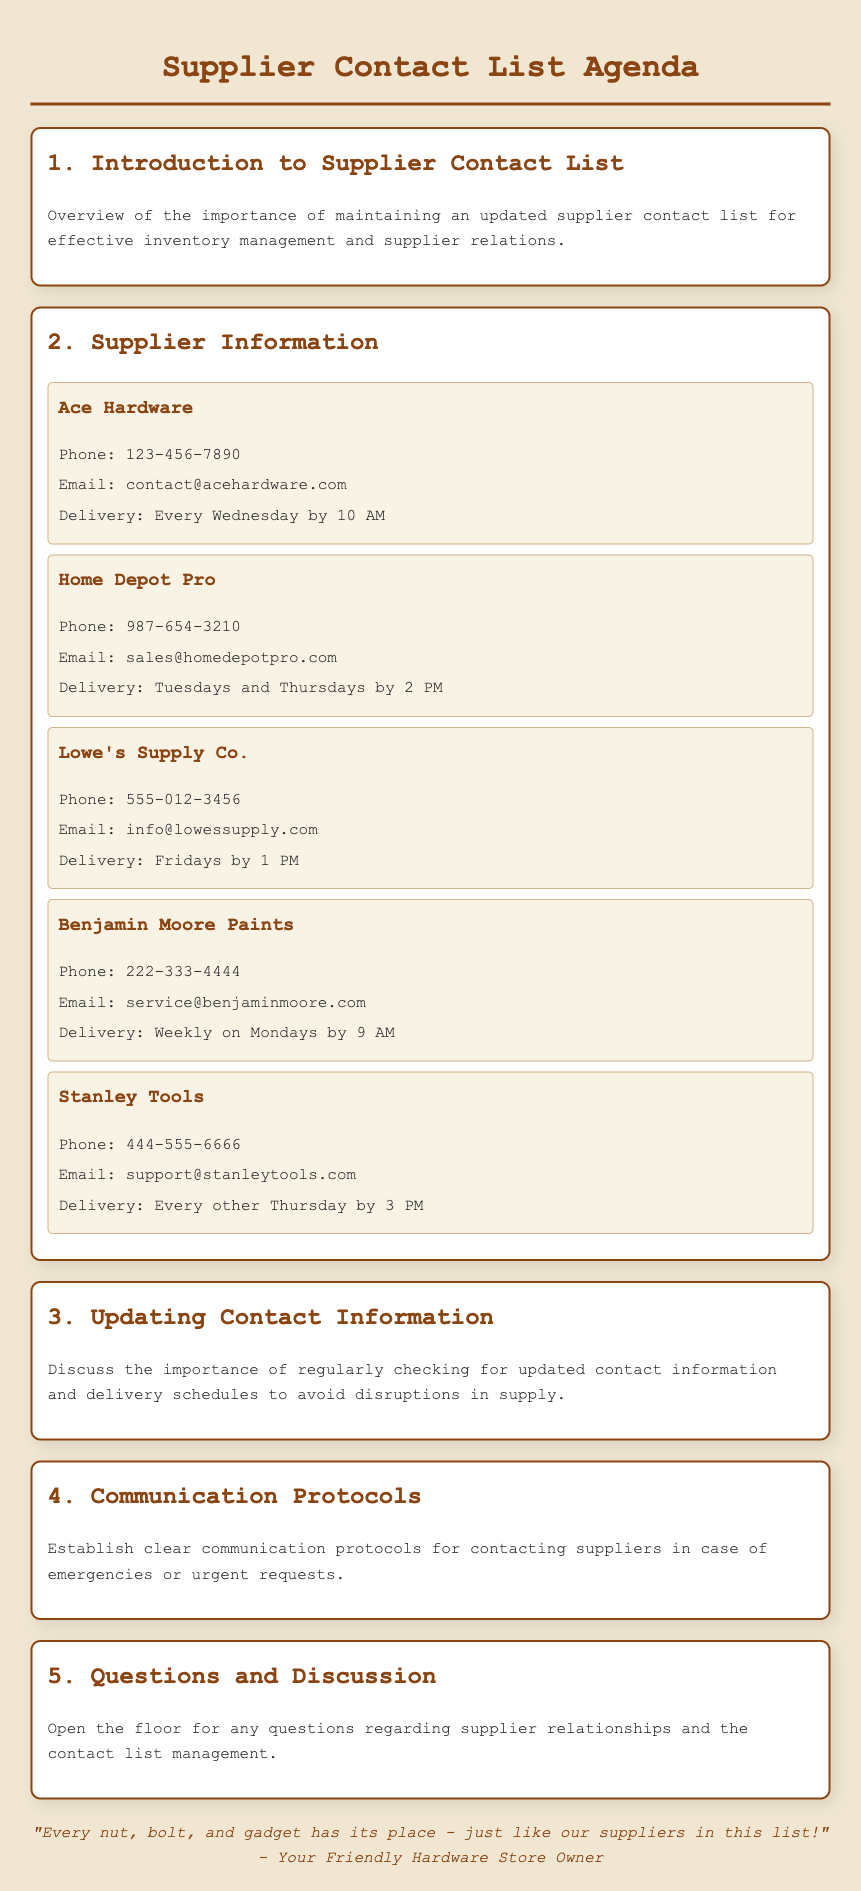What is the phone number for Ace Hardware? The phone number for Ace Hardware is listed in the supplier information section.
Answer: 123-456-7890 What are the delivery days for Home Depot Pro? The delivery days for Home Depot Pro are specified in the supplier information section.
Answer: Tuesdays and Thursdays What is the email address for Stanley Tools? The email address for Stanley Tools is provided in the supplier details.
Answer: support@stanleytools.com How often does Benjamin Moore Paints deliver? The frequency of delivery for Benjamin Moore Paints is mentioned in the document.
Answer: Weekly What is the primary focus of the agenda? The primary focus of the agenda is outlined in the introduction section.
Answer: Supplier Contact List How many suppliers are listed in the document? The number of suppliers can be counted in the supplier information section.
Answer: Five What is the purpose of updating contact information? The purpose is explained in the updating contact information section of the agenda.
Answer: Avoid disruptions in supply What is the color theme of the document? The color theme can be inferred based on the design and background described in the document.
Answer: Warm tones, brown and beige What quote is included at the end of the document? The quote summarizes the owner’s philosophy and is found in the footer section.
Answer: "Every nut, bolt, and gadget has its place - just like our suppliers in this list!" 